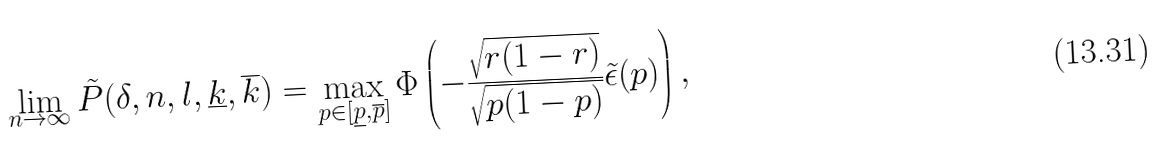<formula> <loc_0><loc_0><loc_500><loc_500>\lim _ { n \to \infty } \tilde { P } ( \delta , n , l , \underline { k } , \overline { k } ) = \max _ { p \in [ \underline { p } , \overline { p } ] } \Phi \left ( - \frac { \sqrt { r ( 1 - r ) } } { \sqrt { p ( 1 - p ) } } \tilde { \epsilon } ( p ) \right ) ,</formula> 